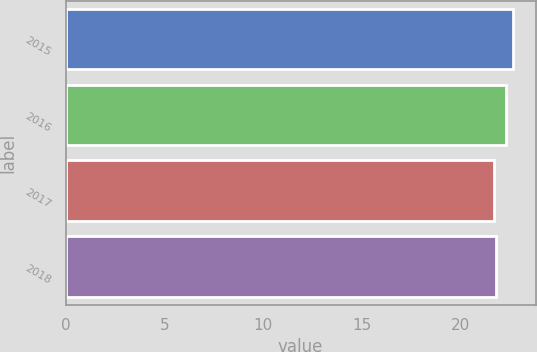Convert chart to OTSL. <chart><loc_0><loc_0><loc_500><loc_500><bar_chart><fcel>2015<fcel>2016<fcel>2017<fcel>2018<nl><fcel>22.7<fcel>22.3<fcel>21.7<fcel>21.8<nl></chart> 